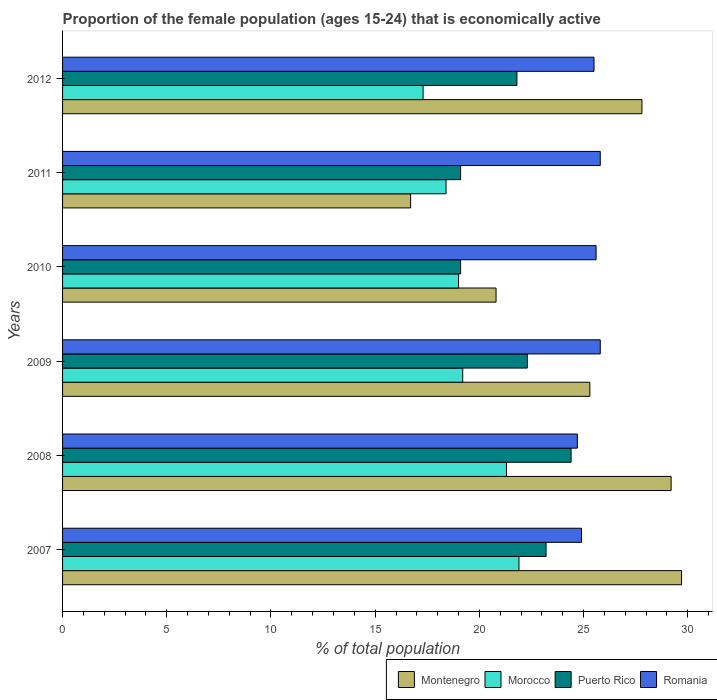Are the number of bars per tick equal to the number of legend labels?
Offer a terse response. Yes. How many bars are there on the 3rd tick from the top?
Your response must be concise. 4. How many bars are there on the 3rd tick from the bottom?
Give a very brief answer. 4. In how many cases, is the number of bars for a given year not equal to the number of legend labels?
Ensure brevity in your answer.  0. What is the proportion of the female population that is economically active in Montenegro in 2011?
Provide a succinct answer. 16.7. Across all years, what is the maximum proportion of the female population that is economically active in Montenegro?
Provide a succinct answer. 29.7. Across all years, what is the minimum proportion of the female population that is economically active in Puerto Rico?
Your answer should be compact. 19.1. What is the total proportion of the female population that is economically active in Montenegro in the graph?
Your answer should be compact. 149.5. What is the difference between the proportion of the female population that is economically active in Romania in 2010 and that in 2011?
Your answer should be compact. -0.2. What is the difference between the proportion of the female population that is economically active in Morocco in 2008 and the proportion of the female population that is economically active in Romania in 2007?
Your answer should be compact. -3.6. What is the average proportion of the female population that is economically active in Morocco per year?
Your answer should be compact. 19.52. In how many years, is the proportion of the female population that is economically active in Morocco greater than 27 %?
Keep it short and to the point. 0. What is the ratio of the proportion of the female population that is economically active in Romania in 2009 to that in 2012?
Provide a succinct answer. 1.01. Is the difference between the proportion of the female population that is economically active in Romania in 2007 and 2010 greater than the difference between the proportion of the female population that is economically active in Puerto Rico in 2007 and 2010?
Keep it short and to the point. No. What is the difference between the highest and the second highest proportion of the female population that is economically active in Puerto Rico?
Provide a succinct answer. 1.2. In how many years, is the proportion of the female population that is economically active in Puerto Rico greater than the average proportion of the female population that is economically active in Puerto Rico taken over all years?
Make the answer very short. 4. Is it the case that in every year, the sum of the proportion of the female population that is economically active in Romania and proportion of the female population that is economically active in Montenegro is greater than the sum of proportion of the female population that is economically active in Puerto Rico and proportion of the female population that is economically active in Morocco?
Offer a terse response. Yes. What does the 2nd bar from the top in 2008 represents?
Your response must be concise. Puerto Rico. What does the 1st bar from the bottom in 2009 represents?
Offer a very short reply. Montenegro. Is it the case that in every year, the sum of the proportion of the female population that is economically active in Morocco and proportion of the female population that is economically active in Romania is greater than the proportion of the female population that is economically active in Montenegro?
Ensure brevity in your answer.  Yes. Are all the bars in the graph horizontal?
Make the answer very short. Yes. How many years are there in the graph?
Offer a very short reply. 6. What is the difference between two consecutive major ticks on the X-axis?
Offer a very short reply. 5. Does the graph contain any zero values?
Your response must be concise. No. How many legend labels are there?
Offer a very short reply. 4. How are the legend labels stacked?
Provide a short and direct response. Horizontal. What is the title of the graph?
Offer a very short reply. Proportion of the female population (ages 15-24) that is economically active. What is the label or title of the X-axis?
Ensure brevity in your answer.  % of total population. What is the % of total population of Montenegro in 2007?
Make the answer very short. 29.7. What is the % of total population in Morocco in 2007?
Provide a short and direct response. 21.9. What is the % of total population of Puerto Rico in 2007?
Offer a terse response. 23.2. What is the % of total population in Romania in 2007?
Your response must be concise. 24.9. What is the % of total population in Montenegro in 2008?
Give a very brief answer. 29.2. What is the % of total population of Morocco in 2008?
Ensure brevity in your answer.  21.3. What is the % of total population of Puerto Rico in 2008?
Provide a succinct answer. 24.4. What is the % of total population in Romania in 2008?
Keep it short and to the point. 24.7. What is the % of total population in Montenegro in 2009?
Ensure brevity in your answer.  25.3. What is the % of total population in Morocco in 2009?
Provide a succinct answer. 19.2. What is the % of total population of Puerto Rico in 2009?
Offer a very short reply. 22.3. What is the % of total population in Romania in 2009?
Make the answer very short. 25.8. What is the % of total population in Montenegro in 2010?
Provide a succinct answer. 20.8. What is the % of total population of Morocco in 2010?
Provide a short and direct response. 19. What is the % of total population of Puerto Rico in 2010?
Give a very brief answer. 19.1. What is the % of total population of Romania in 2010?
Provide a short and direct response. 25.6. What is the % of total population of Montenegro in 2011?
Your answer should be compact. 16.7. What is the % of total population in Morocco in 2011?
Give a very brief answer. 18.4. What is the % of total population of Puerto Rico in 2011?
Provide a short and direct response. 19.1. What is the % of total population in Romania in 2011?
Offer a terse response. 25.8. What is the % of total population in Montenegro in 2012?
Your answer should be compact. 27.8. What is the % of total population in Morocco in 2012?
Provide a short and direct response. 17.3. What is the % of total population of Puerto Rico in 2012?
Provide a short and direct response. 21.8. Across all years, what is the maximum % of total population of Montenegro?
Your answer should be compact. 29.7. Across all years, what is the maximum % of total population in Morocco?
Provide a short and direct response. 21.9. Across all years, what is the maximum % of total population in Puerto Rico?
Your answer should be very brief. 24.4. Across all years, what is the maximum % of total population in Romania?
Your answer should be compact. 25.8. Across all years, what is the minimum % of total population of Montenegro?
Ensure brevity in your answer.  16.7. Across all years, what is the minimum % of total population in Morocco?
Offer a terse response. 17.3. Across all years, what is the minimum % of total population of Puerto Rico?
Your answer should be compact. 19.1. Across all years, what is the minimum % of total population in Romania?
Your answer should be very brief. 24.7. What is the total % of total population of Montenegro in the graph?
Make the answer very short. 149.5. What is the total % of total population of Morocco in the graph?
Provide a succinct answer. 117.1. What is the total % of total population in Puerto Rico in the graph?
Keep it short and to the point. 129.9. What is the total % of total population of Romania in the graph?
Provide a short and direct response. 152.3. What is the difference between the % of total population in Montenegro in 2007 and that in 2008?
Offer a terse response. 0.5. What is the difference between the % of total population of Puerto Rico in 2007 and that in 2008?
Your answer should be compact. -1.2. What is the difference between the % of total population in Morocco in 2007 and that in 2009?
Keep it short and to the point. 2.7. What is the difference between the % of total population of Morocco in 2007 and that in 2010?
Your response must be concise. 2.9. What is the difference between the % of total population in Puerto Rico in 2007 and that in 2010?
Provide a succinct answer. 4.1. What is the difference between the % of total population of Montenegro in 2007 and that in 2011?
Your response must be concise. 13. What is the difference between the % of total population of Puerto Rico in 2007 and that in 2011?
Offer a very short reply. 4.1. What is the difference between the % of total population of Morocco in 2007 and that in 2012?
Offer a terse response. 4.6. What is the difference between the % of total population of Romania in 2007 and that in 2012?
Offer a terse response. -0.6. What is the difference between the % of total population of Morocco in 2008 and that in 2009?
Offer a terse response. 2.1. What is the difference between the % of total population in Romania in 2008 and that in 2009?
Your answer should be very brief. -1.1. What is the difference between the % of total population of Morocco in 2008 and that in 2010?
Your answer should be very brief. 2.3. What is the difference between the % of total population in Puerto Rico in 2008 and that in 2010?
Offer a terse response. 5.3. What is the difference between the % of total population of Romania in 2008 and that in 2010?
Your answer should be very brief. -0.9. What is the difference between the % of total population of Montenegro in 2008 and that in 2011?
Your answer should be compact. 12.5. What is the difference between the % of total population in Puerto Rico in 2008 and that in 2011?
Your answer should be compact. 5.3. What is the difference between the % of total population of Romania in 2008 and that in 2011?
Provide a succinct answer. -1.1. What is the difference between the % of total population of Morocco in 2008 and that in 2012?
Ensure brevity in your answer.  4. What is the difference between the % of total population of Puerto Rico in 2008 and that in 2012?
Make the answer very short. 2.6. What is the difference between the % of total population of Montenegro in 2009 and that in 2010?
Ensure brevity in your answer.  4.5. What is the difference between the % of total population in Morocco in 2009 and that in 2010?
Your answer should be compact. 0.2. What is the difference between the % of total population of Puerto Rico in 2009 and that in 2010?
Ensure brevity in your answer.  3.2. What is the difference between the % of total population in Romania in 2009 and that in 2010?
Ensure brevity in your answer.  0.2. What is the difference between the % of total population of Morocco in 2009 and that in 2011?
Ensure brevity in your answer.  0.8. What is the difference between the % of total population in Puerto Rico in 2009 and that in 2011?
Make the answer very short. 3.2. What is the difference between the % of total population of Montenegro in 2009 and that in 2012?
Ensure brevity in your answer.  -2.5. What is the difference between the % of total population in Puerto Rico in 2009 and that in 2012?
Your answer should be compact. 0.5. What is the difference between the % of total population in Morocco in 2010 and that in 2011?
Make the answer very short. 0.6. What is the difference between the % of total population of Puerto Rico in 2010 and that in 2011?
Give a very brief answer. 0. What is the difference between the % of total population of Romania in 2010 and that in 2011?
Your response must be concise. -0.2. What is the difference between the % of total population of Montenegro in 2010 and that in 2012?
Provide a succinct answer. -7. What is the difference between the % of total population in Puerto Rico in 2010 and that in 2012?
Offer a very short reply. -2.7. What is the difference between the % of total population of Romania in 2010 and that in 2012?
Ensure brevity in your answer.  0.1. What is the difference between the % of total population in Montenegro in 2011 and that in 2012?
Keep it short and to the point. -11.1. What is the difference between the % of total population in Romania in 2011 and that in 2012?
Your response must be concise. 0.3. What is the difference between the % of total population in Montenegro in 2007 and the % of total population in Morocco in 2008?
Your response must be concise. 8.4. What is the difference between the % of total population of Morocco in 2007 and the % of total population of Puerto Rico in 2008?
Provide a short and direct response. -2.5. What is the difference between the % of total population in Morocco in 2007 and the % of total population in Romania in 2008?
Your answer should be compact. -2.8. What is the difference between the % of total population in Puerto Rico in 2007 and the % of total population in Romania in 2008?
Your response must be concise. -1.5. What is the difference between the % of total population of Montenegro in 2007 and the % of total population of Puerto Rico in 2009?
Your answer should be very brief. 7.4. What is the difference between the % of total population of Morocco in 2007 and the % of total population of Puerto Rico in 2009?
Your response must be concise. -0.4. What is the difference between the % of total population of Morocco in 2007 and the % of total population of Romania in 2009?
Your answer should be very brief. -3.9. What is the difference between the % of total population in Montenegro in 2007 and the % of total population in Puerto Rico in 2010?
Your answer should be very brief. 10.6. What is the difference between the % of total population of Montenegro in 2007 and the % of total population of Romania in 2010?
Provide a short and direct response. 4.1. What is the difference between the % of total population in Morocco in 2007 and the % of total population in Puerto Rico in 2010?
Ensure brevity in your answer.  2.8. What is the difference between the % of total population of Puerto Rico in 2007 and the % of total population of Romania in 2010?
Your response must be concise. -2.4. What is the difference between the % of total population of Montenegro in 2007 and the % of total population of Puerto Rico in 2011?
Provide a short and direct response. 10.6. What is the difference between the % of total population in Montenegro in 2007 and the % of total population in Romania in 2011?
Your answer should be very brief. 3.9. What is the difference between the % of total population in Morocco in 2007 and the % of total population in Puerto Rico in 2011?
Give a very brief answer. 2.8. What is the difference between the % of total population of Morocco in 2007 and the % of total population of Romania in 2011?
Your answer should be compact. -3.9. What is the difference between the % of total population in Montenegro in 2007 and the % of total population in Romania in 2012?
Keep it short and to the point. 4.2. What is the difference between the % of total population of Morocco in 2007 and the % of total population of Romania in 2012?
Offer a very short reply. -3.6. What is the difference between the % of total population in Montenegro in 2008 and the % of total population in Morocco in 2009?
Keep it short and to the point. 10. What is the difference between the % of total population in Montenegro in 2008 and the % of total population in Morocco in 2010?
Keep it short and to the point. 10.2. What is the difference between the % of total population in Montenegro in 2008 and the % of total population in Puerto Rico in 2010?
Keep it short and to the point. 10.1. What is the difference between the % of total population in Puerto Rico in 2008 and the % of total population in Romania in 2010?
Your response must be concise. -1.2. What is the difference between the % of total population in Montenegro in 2008 and the % of total population in Puerto Rico in 2011?
Make the answer very short. 10.1. What is the difference between the % of total population in Montenegro in 2008 and the % of total population in Romania in 2011?
Offer a terse response. 3.4. What is the difference between the % of total population in Morocco in 2008 and the % of total population in Puerto Rico in 2011?
Keep it short and to the point. 2.2. What is the difference between the % of total population in Morocco in 2008 and the % of total population in Romania in 2011?
Offer a terse response. -4.5. What is the difference between the % of total population in Montenegro in 2008 and the % of total population in Morocco in 2012?
Your response must be concise. 11.9. What is the difference between the % of total population of Montenegro in 2008 and the % of total population of Puerto Rico in 2012?
Offer a very short reply. 7.4. What is the difference between the % of total population in Montenegro in 2008 and the % of total population in Romania in 2012?
Offer a very short reply. 3.7. What is the difference between the % of total population in Morocco in 2008 and the % of total population in Puerto Rico in 2012?
Offer a terse response. -0.5. What is the difference between the % of total population of Montenegro in 2009 and the % of total population of Morocco in 2010?
Provide a succinct answer. 6.3. What is the difference between the % of total population in Puerto Rico in 2009 and the % of total population in Romania in 2010?
Your response must be concise. -3.3. What is the difference between the % of total population in Montenegro in 2009 and the % of total population in Puerto Rico in 2011?
Offer a terse response. 6.2. What is the difference between the % of total population in Montenegro in 2009 and the % of total population in Romania in 2011?
Make the answer very short. -0.5. What is the difference between the % of total population of Morocco in 2009 and the % of total population of Puerto Rico in 2011?
Ensure brevity in your answer.  0.1. What is the difference between the % of total population of Morocco in 2009 and the % of total population of Romania in 2011?
Your answer should be very brief. -6.6. What is the difference between the % of total population in Puerto Rico in 2009 and the % of total population in Romania in 2011?
Keep it short and to the point. -3.5. What is the difference between the % of total population in Montenegro in 2009 and the % of total population in Puerto Rico in 2012?
Give a very brief answer. 3.5. What is the difference between the % of total population of Montenegro in 2010 and the % of total population of Morocco in 2011?
Your answer should be compact. 2.4. What is the difference between the % of total population in Montenegro in 2010 and the % of total population in Romania in 2011?
Offer a terse response. -5. What is the difference between the % of total population of Morocco in 2010 and the % of total population of Romania in 2011?
Your answer should be very brief. -6.8. What is the difference between the % of total population in Puerto Rico in 2010 and the % of total population in Romania in 2011?
Your response must be concise. -6.7. What is the difference between the % of total population of Montenegro in 2011 and the % of total population of Morocco in 2012?
Provide a short and direct response. -0.6. What is the difference between the % of total population of Montenegro in 2011 and the % of total population of Puerto Rico in 2012?
Give a very brief answer. -5.1. What is the difference between the % of total population in Morocco in 2011 and the % of total population in Puerto Rico in 2012?
Provide a succinct answer. -3.4. What is the difference between the % of total population of Puerto Rico in 2011 and the % of total population of Romania in 2012?
Provide a short and direct response. -6.4. What is the average % of total population of Montenegro per year?
Offer a very short reply. 24.92. What is the average % of total population of Morocco per year?
Provide a short and direct response. 19.52. What is the average % of total population of Puerto Rico per year?
Your response must be concise. 21.65. What is the average % of total population in Romania per year?
Your response must be concise. 25.38. In the year 2007, what is the difference between the % of total population in Montenegro and % of total population in Romania?
Your answer should be very brief. 4.8. In the year 2007, what is the difference between the % of total population in Morocco and % of total population in Puerto Rico?
Your response must be concise. -1.3. In the year 2007, what is the difference between the % of total population in Puerto Rico and % of total population in Romania?
Make the answer very short. -1.7. In the year 2008, what is the difference between the % of total population of Montenegro and % of total population of Puerto Rico?
Provide a succinct answer. 4.8. In the year 2008, what is the difference between the % of total population of Morocco and % of total population of Romania?
Your response must be concise. -3.4. In the year 2008, what is the difference between the % of total population of Puerto Rico and % of total population of Romania?
Your answer should be compact. -0.3. In the year 2009, what is the difference between the % of total population in Morocco and % of total population in Puerto Rico?
Offer a very short reply. -3.1. In the year 2009, what is the difference between the % of total population in Puerto Rico and % of total population in Romania?
Provide a short and direct response. -3.5. In the year 2010, what is the difference between the % of total population in Montenegro and % of total population in Morocco?
Provide a short and direct response. 1.8. In the year 2010, what is the difference between the % of total population in Montenegro and % of total population in Puerto Rico?
Give a very brief answer. 1.7. In the year 2010, what is the difference between the % of total population in Montenegro and % of total population in Romania?
Offer a very short reply. -4.8. In the year 2010, what is the difference between the % of total population in Morocco and % of total population in Puerto Rico?
Your answer should be very brief. -0.1. In the year 2011, what is the difference between the % of total population of Montenegro and % of total population of Romania?
Your response must be concise. -9.1. In the year 2011, what is the difference between the % of total population of Morocco and % of total population of Romania?
Give a very brief answer. -7.4. In the year 2012, what is the difference between the % of total population of Montenegro and % of total population of Morocco?
Ensure brevity in your answer.  10.5. In the year 2012, what is the difference between the % of total population in Montenegro and % of total population in Puerto Rico?
Your answer should be compact. 6. In the year 2012, what is the difference between the % of total population in Morocco and % of total population in Puerto Rico?
Ensure brevity in your answer.  -4.5. In the year 2012, what is the difference between the % of total population in Morocco and % of total population in Romania?
Keep it short and to the point. -8.2. In the year 2012, what is the difference between the % of total population of Puerto Rico and % of total population of Romania?
Provide a succinct answer. -3.7. What is the ratio of the % of total population in Montenegro in 2007 to that in 2008?
Your response must be concise. 1.02. What is the ratio of the % of total population of Morocco in 2007 to that in 2008?
Give a very brief answer. 1.03. What is the ratio of the % of total population in Puerto Rico in 2007 to that in 2008?
Ensure brevity in your answer.  0.95. What is the ratio of the % of total population of Romania in 2007 to that in 2008?
Keep it short and to the point. 1.01. What is the ratio of the % of total population of Montenegro in 2007 to that in 2009?
Provide a short and direct response. 1.17. What is the ratio of the % of total population of Morocco in 2007 to that in 2009?
Your answer should be compact. 1.14. What is the ratio of the % of total population of Puerto Rico in 2007 to that in 2009?
Ensure brevity in your answer.  1.04. What is the ratio of the % of total population of Romania in 2007 to that in 2009?
Make the answer very short. 0.97. What is the ratio of the % of total population in Montenegro in 2007 to that in 2010?
Make the answer very short. 1.43. What is the ratio of the % of total population of Morocco in 2007 to that in 2010?
Your answer should be compact. 1.15. What is the ratio of the % of total population in Puerto Rico in 2007 to that in 2010?
Give a very brief answer. 1.21. What is the ratio of the % of total population of Romania in 2007 to that in 2010?
Give a very brief answer. 0.97. What is the ratio of the % of total population in Montenegro in 2007 to that in 2011?
Make the answer very short. 1.78. What is the ratio of the % of total population of Morocco in 2007 to that in 2011?
Make the answer very short. 1.19. What is the ratio of the % of total population of Puerto Rico in 2007 to that in 2011?
Offer a very short reply. 1.21. What is the ratio of the % of total population in Romania in 2007 to that in 2011?
Give a very brief answer. 0.97. What is the ratio of the % of total population of Montenegro in 2007 to that in 2012?
Offer a very short reply. 1.07. What is the ratio of the % of total population in Morocco in 2007 to that in 2012?
Give a very brief answer. 1.27. What is the ratio of the % of total population of Puerto Rico in 2007 to that in 2012?
Offer a very short reply. 1.06. What is the ratio of the % of total population in Romania in 2007 to that in 2012?
Provide a short and direct response. 0.98. What is the ratio of the % of total population of Montenegro in 2008 to that in 2009?
Your response must be concise. 1.15. What is the ratio of the % of total population in Morocco in 2008 to that in 2009?
Provide a succinct answer. 1.11. What is the ratio of the % of total population of Puerto Rico in 2008 to that in 2009?
Keep it short and to the point. 1.09. What is the ratio of the % of total population of Romania in 2008 to that in 2009?
Your answer should be compact. 0.96. What is the ratio of the % of total population in Montenegro in 2008 to that in 2010?
Your response must be concise. 1.4. What is the ratio of the % of total population in Morocco in 2008 to that in 2010?
Make the answer very short. 1.12. What is the ratio of the % of total population in Puerto Rico in 2008 to that in 2010?
Provide a succinct answer. 1.28. What is the ratio of the % of total population in Romania in 2008 to that in 2010?
Provide a short and direct response. 0.96. What is the ratio of the % of total population of Montenegro in 2008 to that in 2011?
Your answer should be very brief. 1.75. What is the ratio of the % of total population of Morocco in 2008 to that in 2011?
Offer a very short reply. 1.16. What is the ratio of the % of total population of Puerto Rico in 2008 to that in 2011?
Offer a terse response. 1.28. What is the ratio of the % of total population of Romania in 2008 to that in 2011?
Keep it short and to the point. 0.96. What is the ratio of the % of total population of Montenegro in 2008 to that in 2012?
Offer a terse response. 1.05. What is the ratio of the % of total population of Morocco in 2008 to that in 2012?
Make the answer very short. 1.23. What is the ratio of the % of total population in Puerto Rico in 2008 to that in 2012?
Make the answer very short. 1.12. What is the ratio of the % of total population of Romania in 2008 to that in 2012?
Ensure brevity in your answer.  0.97. What is the ratio of the % of total population in Montenegro in 2009 to that in 2010?
Your answer should be very brief. 1.22. What is the ratio of the % of total population in Morocco in 2009 to that in 2010?
Make the answer very short. 1.01. What is the ratio of the % of total population of Puerto Rico in 2009 to that in 2010?
Your answer should be compact. 1.17. What is the ratio of the % of total population in Romania in 2009 to that in 2010?
Your answer should be very brief. 1.01. What is the ratio of the % of total population of Montenegro in 2009 to that in 2011?
Give a very brief answer. 1.51. What is the ratio of the % of total population of Morocco in 2009 to that in 2011?
Your answer should be compact. 1.04. What is the ratio of the % of total population in Puerto Rico in 2009 to that in 2011?
Ensure brevity in your answer.  1.17. What is the ratio of the % of total population of Montenegro in 2009 to that in 2012?
Keep it short and to the point. 0.91. What is the ratio of the % of total population in Morocco in 2009 to that in 2012?
Your answer should be very brief. 1.11. What is the ratio of the % of total population in Puerto Rico in 2009 to that in 2012?
Your response must be concise. 1.02. What is the ratio of the % of total population of Romania in 2009 to that in 2012?
Ensure brevity in your answer.  1.01. What is the ratio of the % of total population of Montenegro in 2010 to that in 2011?
Keep it short and to the point. 1.25. What is the ratio of the % of total population of Morocco in 2010 to that in 2011?
Make the answer very short. 1.03. What is the ratio of the % of total population of Puerto Rico in 2010 to that in 2011?
Give a very brief answer. 1. What is the ratio of the % of total population in Romania in 2010 to that in 2011?
Give a very brief answer. 0.99. What is the ratio of the % of total population of Montenegro in 2010 to that in 2012?
Give a very brief answer. 0.75. What is the ratio of the % of total population in Morocco in 2010 to that in 2012?
Your answer should be compact. 1.1. What is the ratio of the % of total population in Puerto Rico in 2010 to that in 2012?
Give a very brief answer. 0.88. What is the ratio of the % of total population of Romania in 2010 to that in 2012?
Make the answer very short. 1. What is the ratio of the % of total population of Montenegro in 2011 to that in 2012?
Provide a succinct answer. 0.6. What is the ratio of the % of total population in Morocco in 2011 to that in 2012?
Make the answer very short. 1.06. What is the ratio of the % of total population of Puerto Rico in 2011 to that in 2012?
Make the answer very short. 0.88. What is the ratio of the % of total population in Romania in 2011 to that in 2012?
Offer a terse response. 1.01. What is the difference between the highest and the second highest % of total population of Montenegro?
Offer a very short reply. 0.5. What is the difference between the highest and the second highest % of total population in Morocco?
Keep it short and to the point. 0.6. What is the difference between the highest and the second highest % of total population of Puerto Rico?
Ensure brevity in your answer.  1.2. What is the difference between the highest and the second highest % of total population in Romania?
Offer a very short reply. 0. What is the difference between the highest and the lowest % of total population in Morocco?
Give a very brief answer. 4.6. 